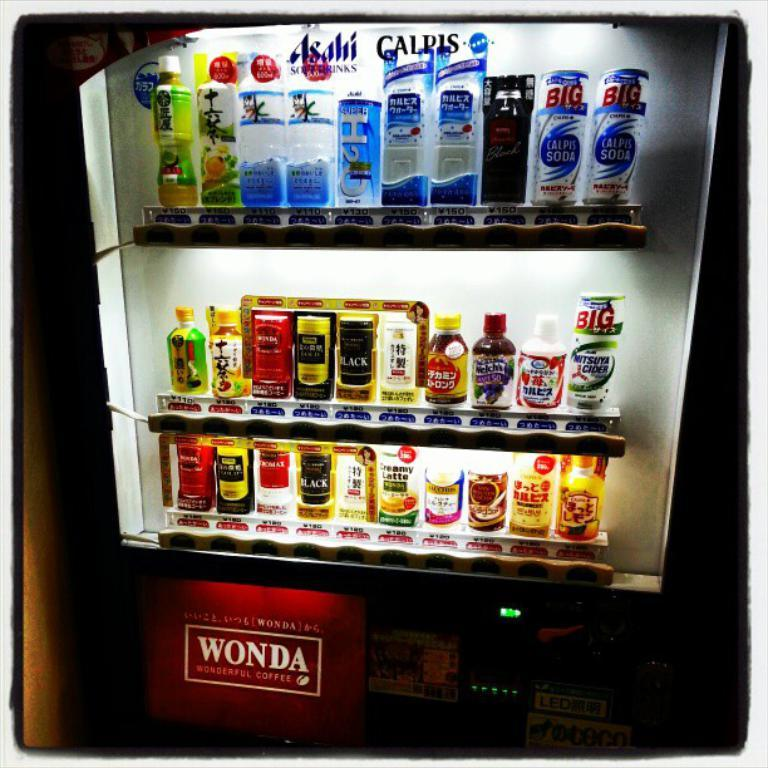<image>
Write a terse but informative summary of the picture. a vending machine reading WONDA with various drinks for sale 